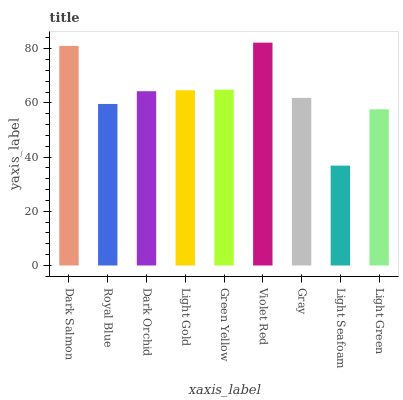Is Light Seafoam the minimum?
Answer yes or no. Yes. Is Violet Red the maximum?
Answer yes or no. Yes. Is Royal Blue the minimum?
Answer yes or no. No. Is Royal Blue the maximum?
Answer yes or no. No. Is Dark Salmon greater than Royal Blue?
Answer yes or no. Yes. Is Royal Blue less than Dark Salmon?
Answer yes or no. Yes. Is Royal Blue greater than Dark Salmon?
Answer yes or no. No. Is Dark Salmon less than Royal Blue?
Answer yes or no. No. Is Dark Orchid the high median?
Answer yes or no. Yes. Is Dark Orchid the low median?
Answer yes or no. Yes. Is Violet Red the high median?
Answer yes or no. No. Is Light Seafoam the low median?
Answer yes or no. No. 